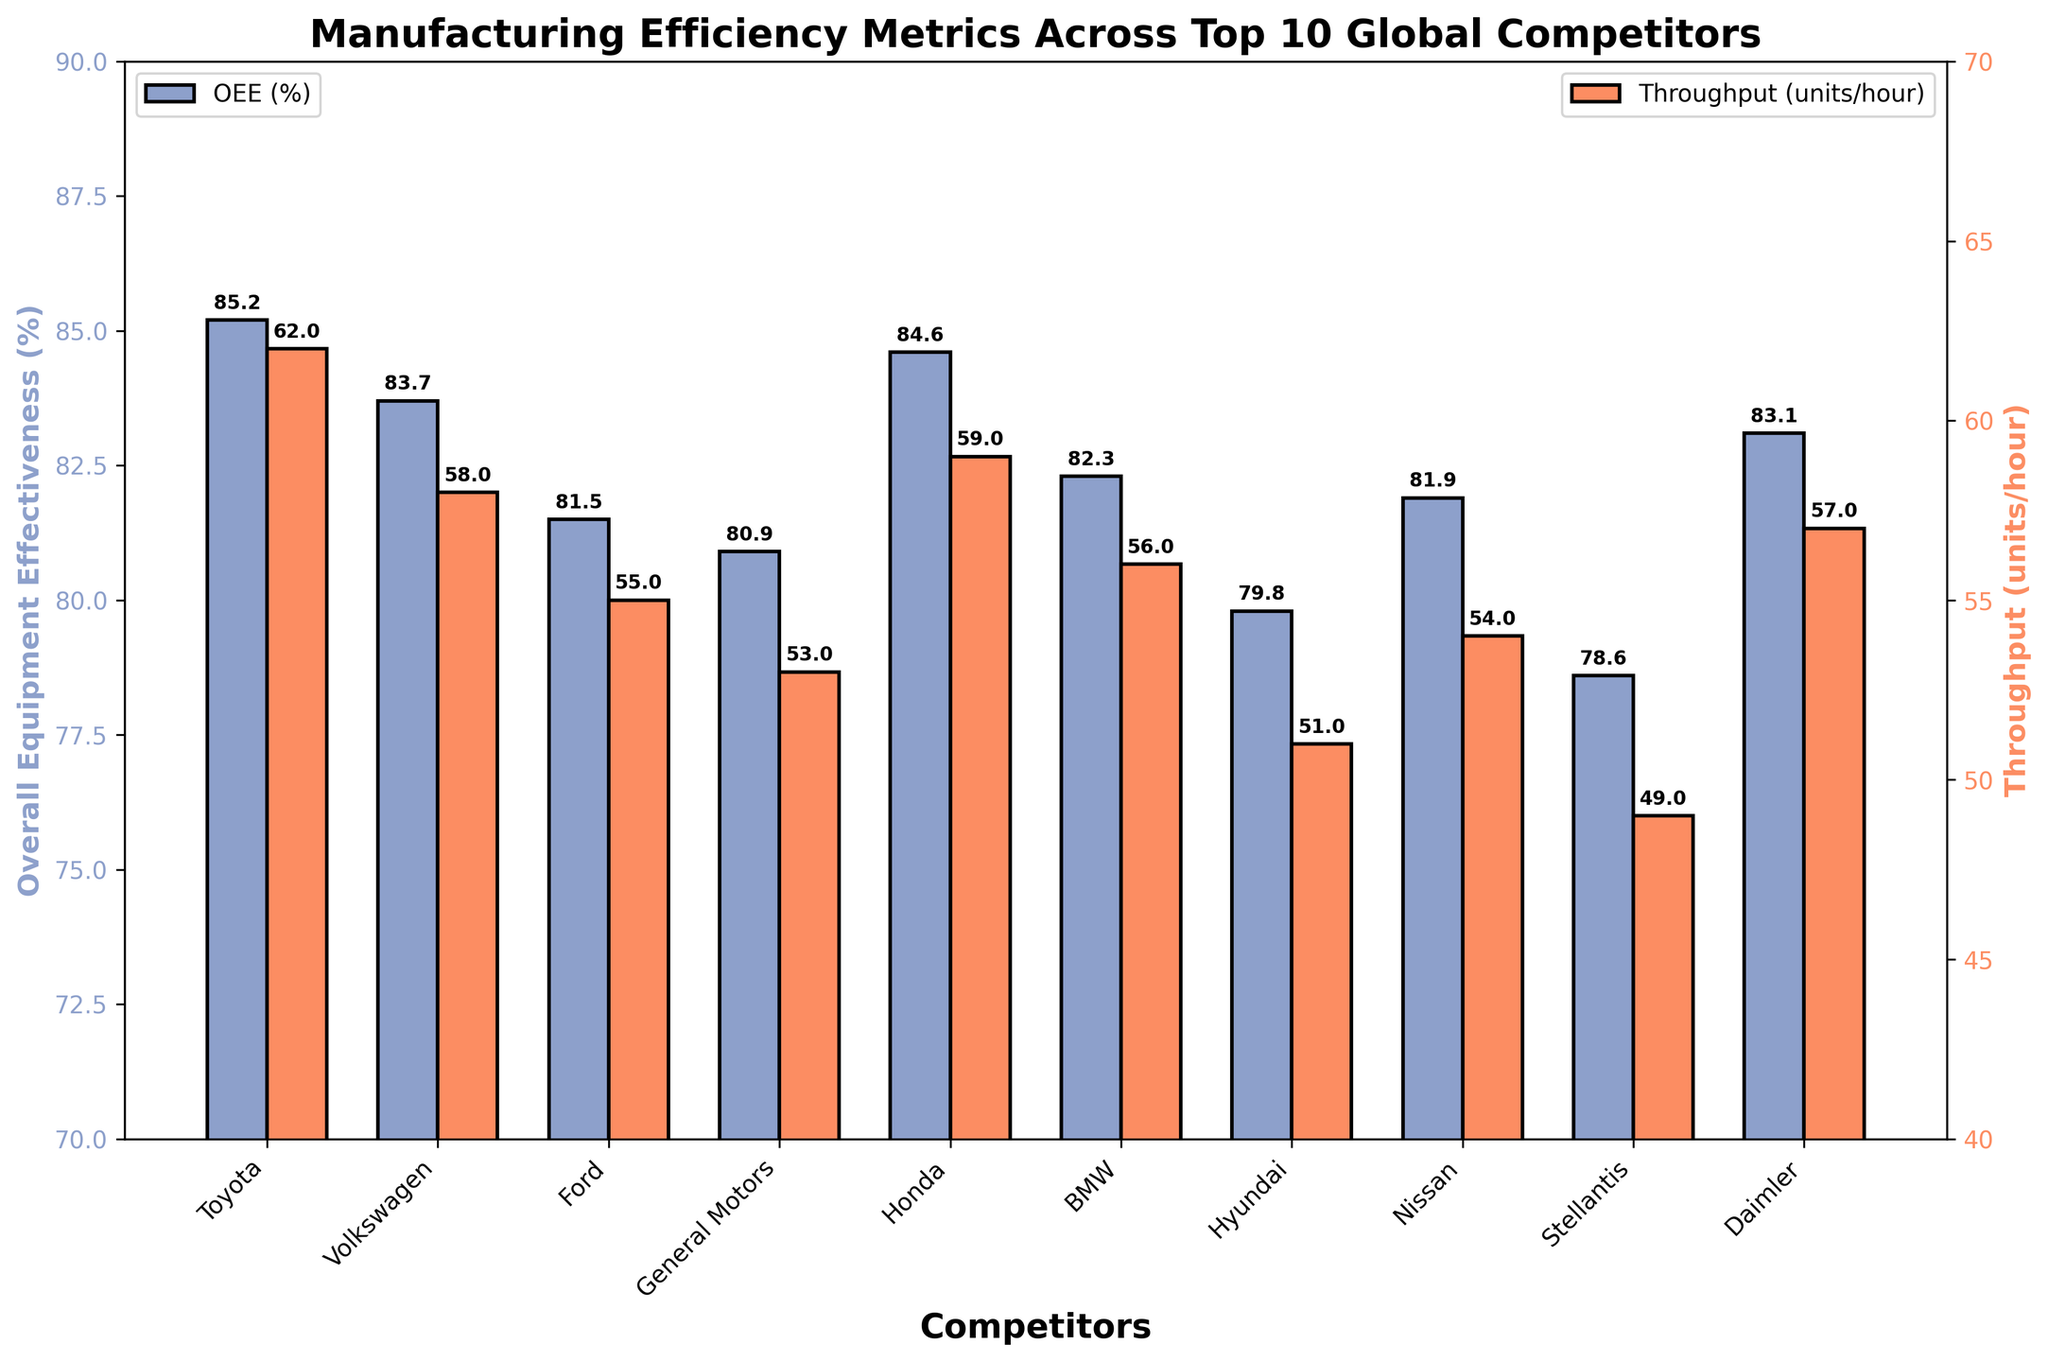What is the Overall Equipment Effectiveness (OEE) of the top-performing competitor? The top-performing competitor has the tallest blue bar in the OEE group. By identifying this, we see that Toyota has an OEE of 85.2%.
Answer: 85.2% Which competitor has the highest throughput? The competitor with the tallest orange bar in the throughput group has the highest throughput. Toyota has the highest throughput with 62 units/hour.
Answer: Toyota What's the difference in OEE between Toyota and Stellantis? Toyota has an OEE of 85.2%, and Stellantis has an OEE of 78.6%. The difference is calculated as 85.2% - 78.6% = 6.6%.
Answer: 6.6% Which competitor shows the smallest OEE? The smallest blue bar in the OEE group indicates the competitor with the smallest OEE. Stellantis has the smallest OEE with 78.6%.
Answer: Stellantis How many competitors have an OEE above 83%? By observing the blue bars in the OEE group, we see that Toyota, Volkswagen, Honda, and Daimler have OEE values above 83%. There are 4 such competitors.
Answer: 4 What's the average throughput of all competitors? To find the average throughput, sum up all the throughput values and divide by the number of competitors. The throughputs are 62 + 58 + 55 + 53 + 59 + 56 + 51 + 54 + 49 + 57 = 554. The number of competitors is 10, so the average throughput is 554/10 = 55.4 units/hour.
Answer: 55.4 Compare the OEE and throughput of Honda and Nissan. Which one has higher values for both metrics? Honda has an OEE of 84.6% and throughput of 59 units/hour. Nissan has an OEE of 81.9% and throughput of 54 units/hour. Honda has higher values for both OEE and throughput compared to Nissan.
Answer: Honda What is the combined throughput of the highest and lowest throughput competitors? Toyota has the highest throughput with 62 units/hour, and Stellantis has the lowest throughput with 49 units/hour. Combined, this is 62 + 49 = 111 units/hour.
Answer: 111 What are the attributes of the competitor with the lowest Throughput? The competitor with the lowest orange bar in the Throughput group is Stellantis, with a throughput of 49 units/hour. It has an OEE of 78.6%.
Answer: Stellantis: Throughput 49, OEE 78.6 Which competitors have throughput values between 50 and 60 units/hour? Competitors with throughput values between 50 and 60 units/hour are Honda (59), Volkswagen (58), Daimler (57), BMW (56), Ford (55), Nissan (54), and General Motors (53).
Answer: Honda, Volkswagen, Daimler, BMW, Ford, Nissan, General Motors 